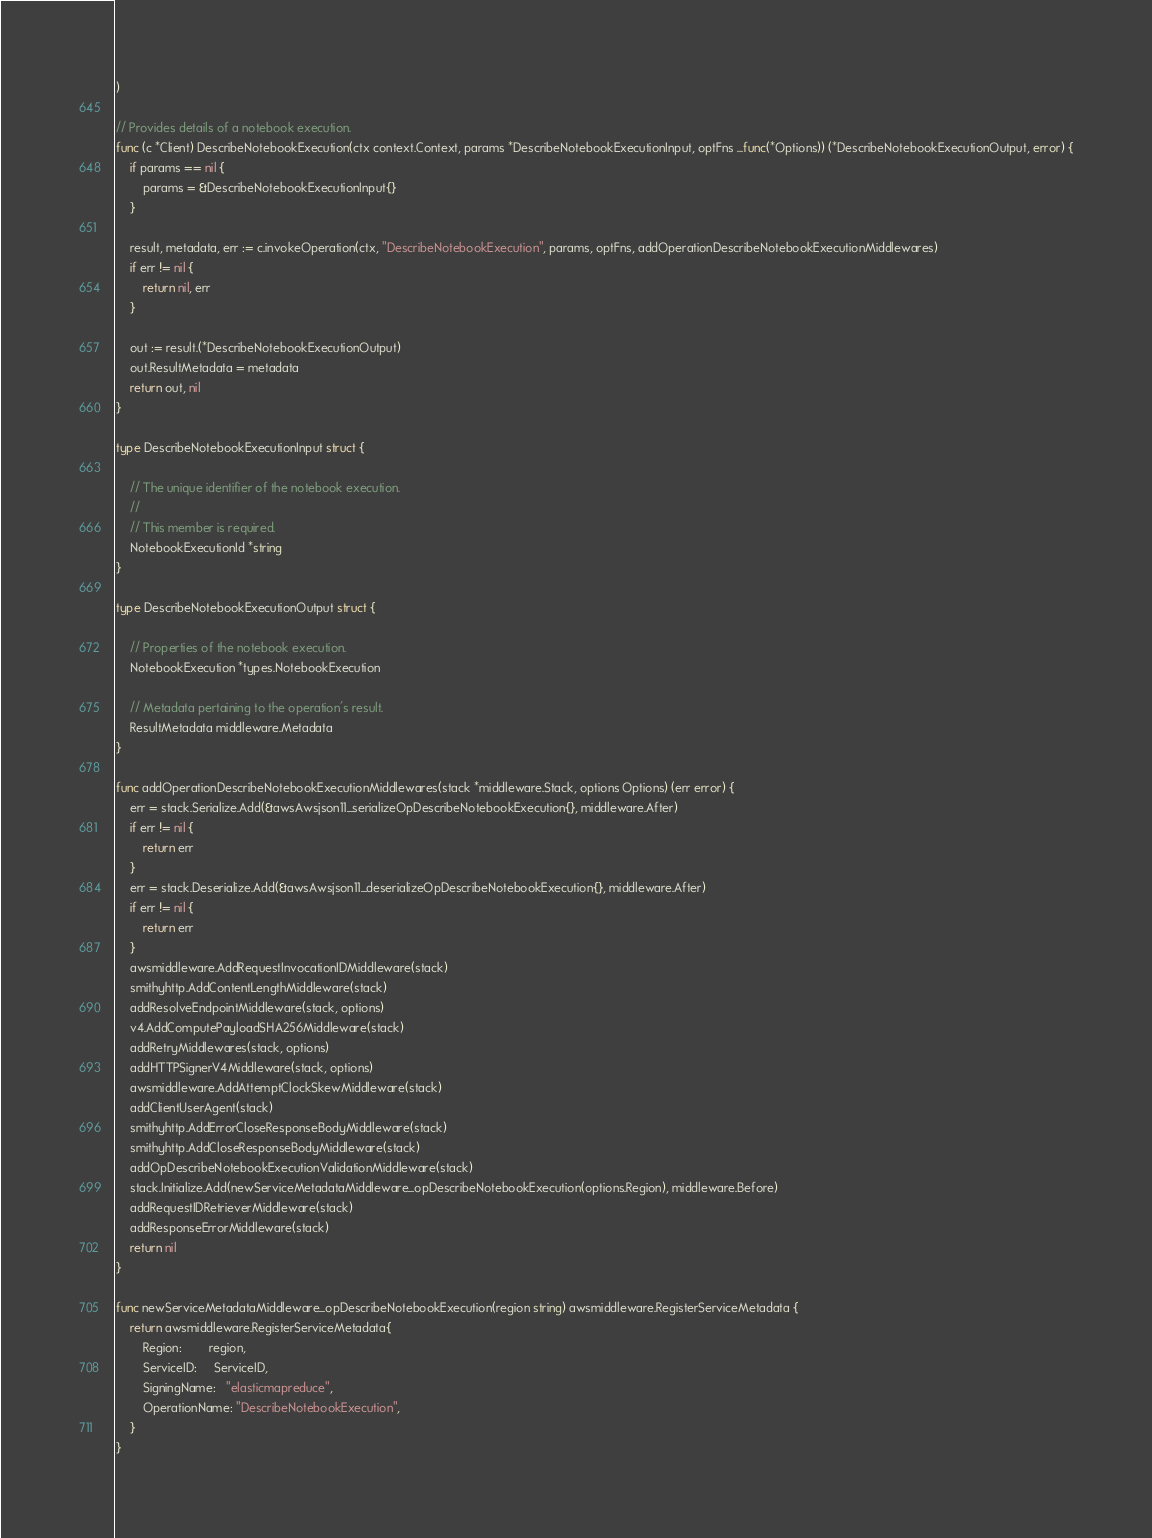<code> <loc_0><loc_0><loc_500><loc_500><_Go_>)

// Provides details of a notebook execution.
func (c *Client) DescribeNotebookExecution(ctx context.Context, params *DescribeNotebookExecutionInput, optFns ...func(*Options)) (*DescribeNotebookExecutionOutput, error) {
	if params == nil {
		params = &DescribeNotebookExecutionInput{}
	}

	result, metadata, err := c.invokeOperation(ctx, "DescribeNotebookExecution", params, optFns, addOperationDescribeNotebookExecutionMiddlewares)
	if err != nil {
		return nil, err
	}

	out := result.(*DescribeNotebookExecutionOutput)
	out.ResultMetadata = metadata
	return out, nil
}

type DescribeNotebookExecutionInput struct {

	// The unique identifier of the notebook execution.
	//
	// This member is required.
	NotebookExecutionId *string
}

type DescribeNotebookExecutionOutput struct {

	// Properties of the notebook execution.
	NotebookExecution *types.NotebookExecution

	// Metadata pertaining to the operation's result.
	ResultMetadata middleware.Metadata
}

func addOperationDescribeNotebookExecutionMiddlewares(stack *middleware.Stack, options Options) (err error) {
	err = stack.Serialize.Add(&awsAwsjson11_serializeOpDescribeNotebookExecution{}, middleware.After)
	if err != nil {
		return err
	}
	err = stack.Deserialize.Add(&awsAwsjson11_deserializeOpDescribeNotebookExecution{}, middleware.After)
	if err != nil {
		return err
	}
	awsmiddleware.AddRequestInvocationIDMiddleware(stack)
	smithyhttp.AddContentLengthMiddleware(stack)
	addResolveEndpointMiddleware(stack, options)
	v4.AddComputePayloadSHA256Middleware(stack)
	addRetryMiddlewares(stack, options)
	addHTTPSignerV4Middleware(stack, options)
	awsmiddleware.AddAttemptClockSkewMiddleware(stack)
	addClientUserAgent(stack)
	smithyhttp.AddErrorCloseResponseBodyMiddleware(stack)
	smithyhttp.AddCloseResponseBodyMiddleware(stack)
	addOpDescribeNotebookExecutionValidationMiddleware(stack)
	stack.Initialize.Add(newServiceMetadataMiddleware_opDescribeNotebookExecution(options.Region), middleware.Before)
	addRequestIDRetrieverMiddleware(stack)
	addResponseErrorMiddleware(stack)
	return nil
}

func newServiceMetadataMiddleware_opDescribeNotebookExecution(region string) awsmiddleware.RegisterServiceMetadata {
	return awsmiddleware.RegisterServiceMetadata{
		Region:        region,
		ServiceID:     ServiceID,
		SigningName:   "elasticmapreduce",
		OperationName: "DescribeNotebookExecution",
	}
}
</code> 